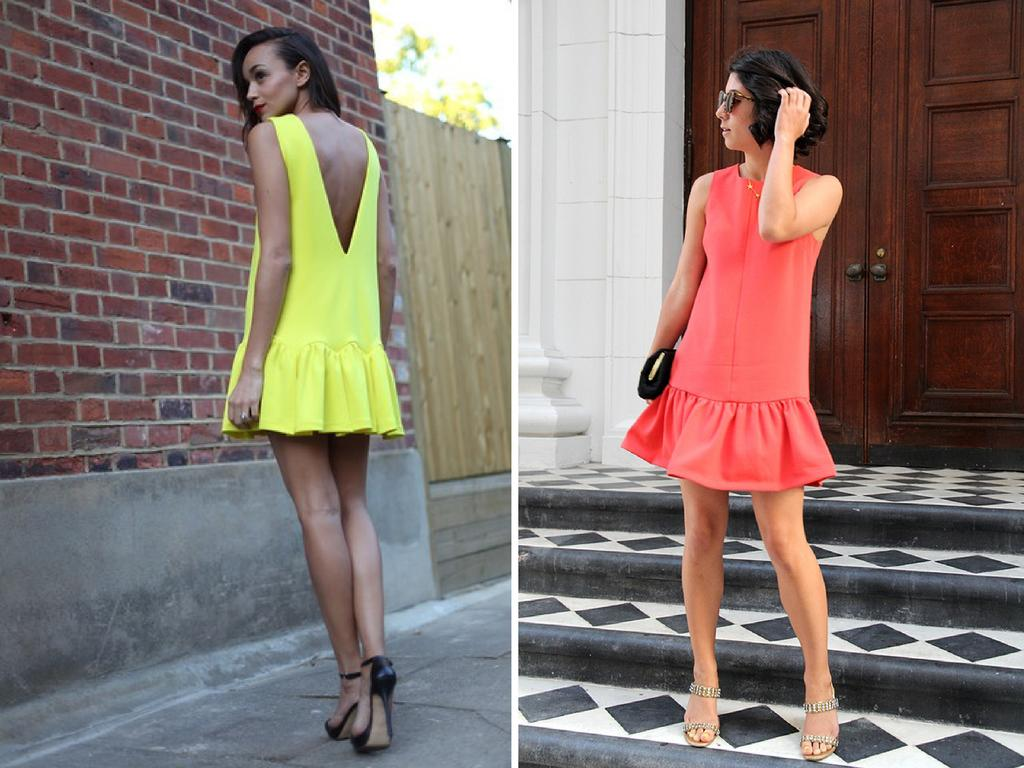How many people are in the image? There are two people in the image. What colors are the dresses of the people in the image? One person is wearing a yellow dress, and the other person is wearing a red dress. What can be seen in the background of the image? There is a door, a brick-wall, a tree, and the sky visible in the background of the image. What type of shade does the tree provide in the image? There is no mention of shade in the image, as it only describes the presence of a tree in the background. What is the temper of the person wearing the yellow dress in the image? There is no indication of the person's temperament in the image, as it only describes their clothing. 